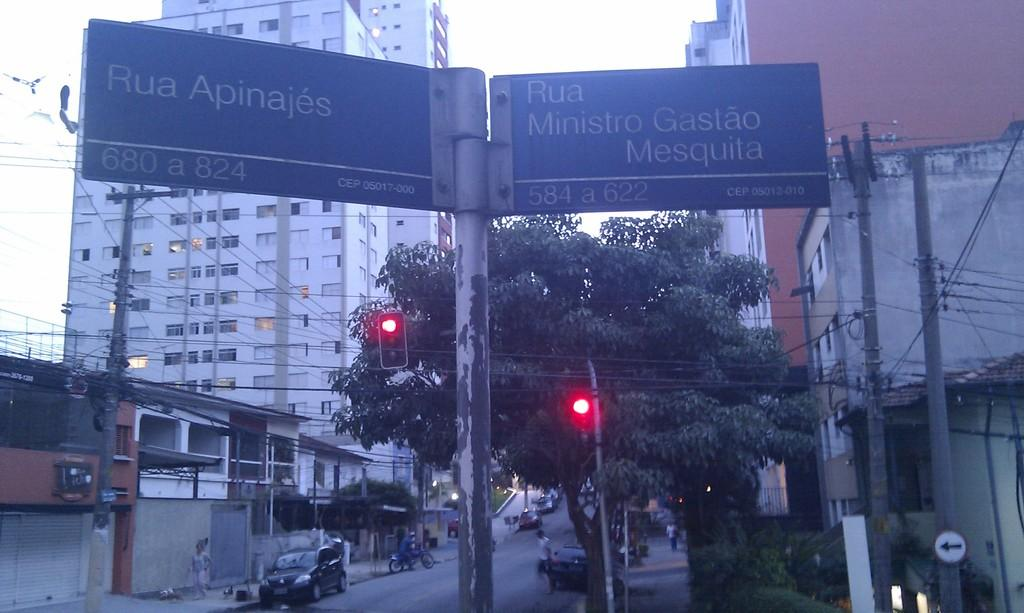<image>
Summarize the visual content of the image. A large sign pole has two signs hanging off either side of it that read Rua apinajes and rua ministro gastao. 